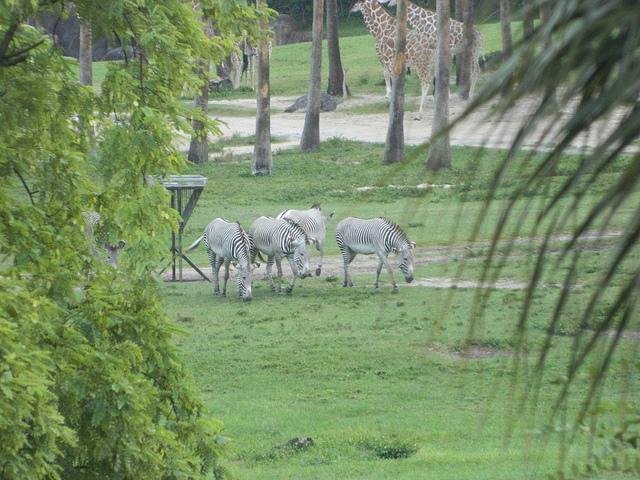Where are these Zebras most likely living together with the giraffes?

Choices:
A) zoo
B) wild
C) house
D) conservatory conservatory 